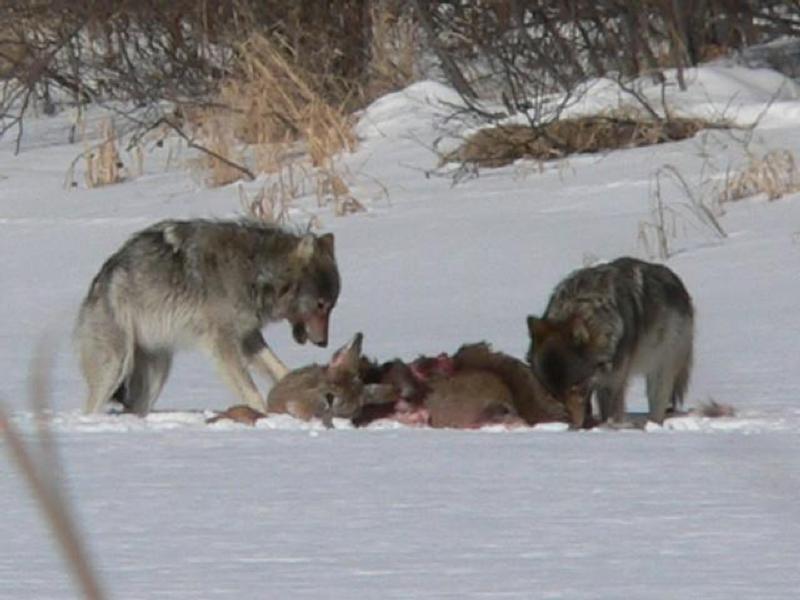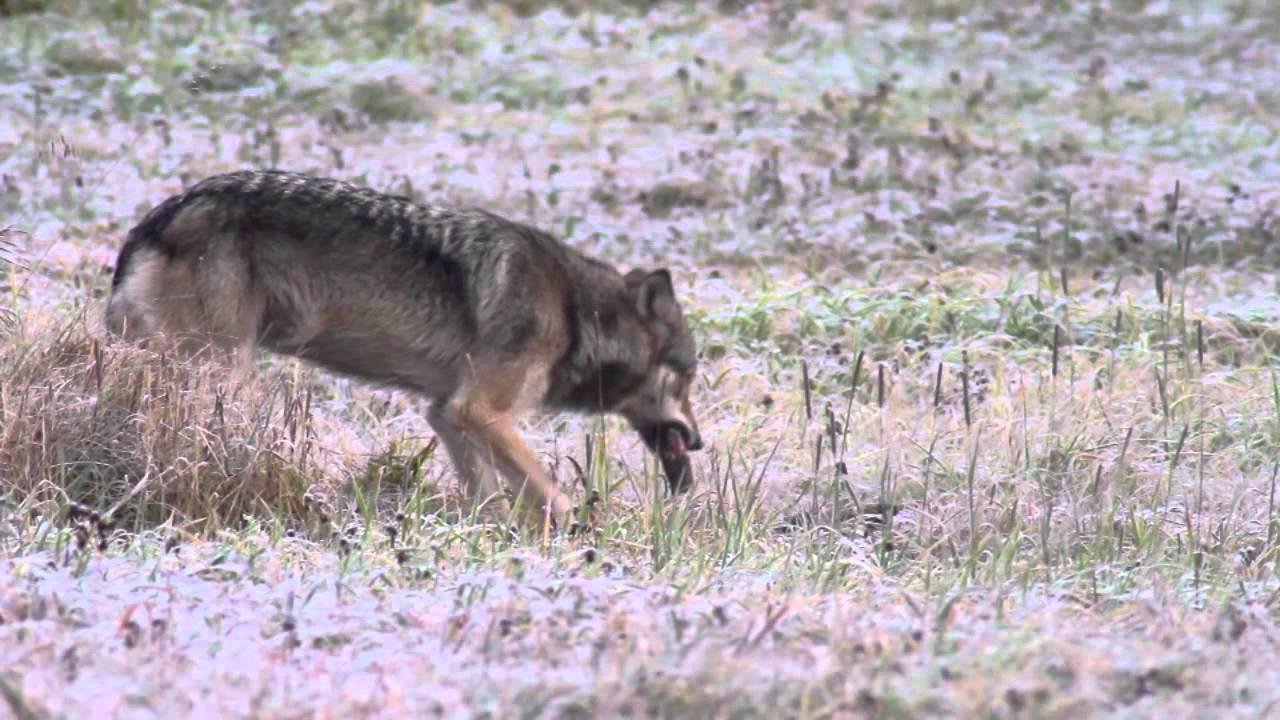The first image is the image on the left, the second image is the image on the right. Given the left and right images, does the statement "One image shows a single wolf carrying something in its mouth." hold true? Answer yes or no. Yes. The first image is the image on the left, the second image is the image on the right. Considering the images on both sides, is "There are exactly three wolves out doors." valid? Answer yes or no. Yes. 